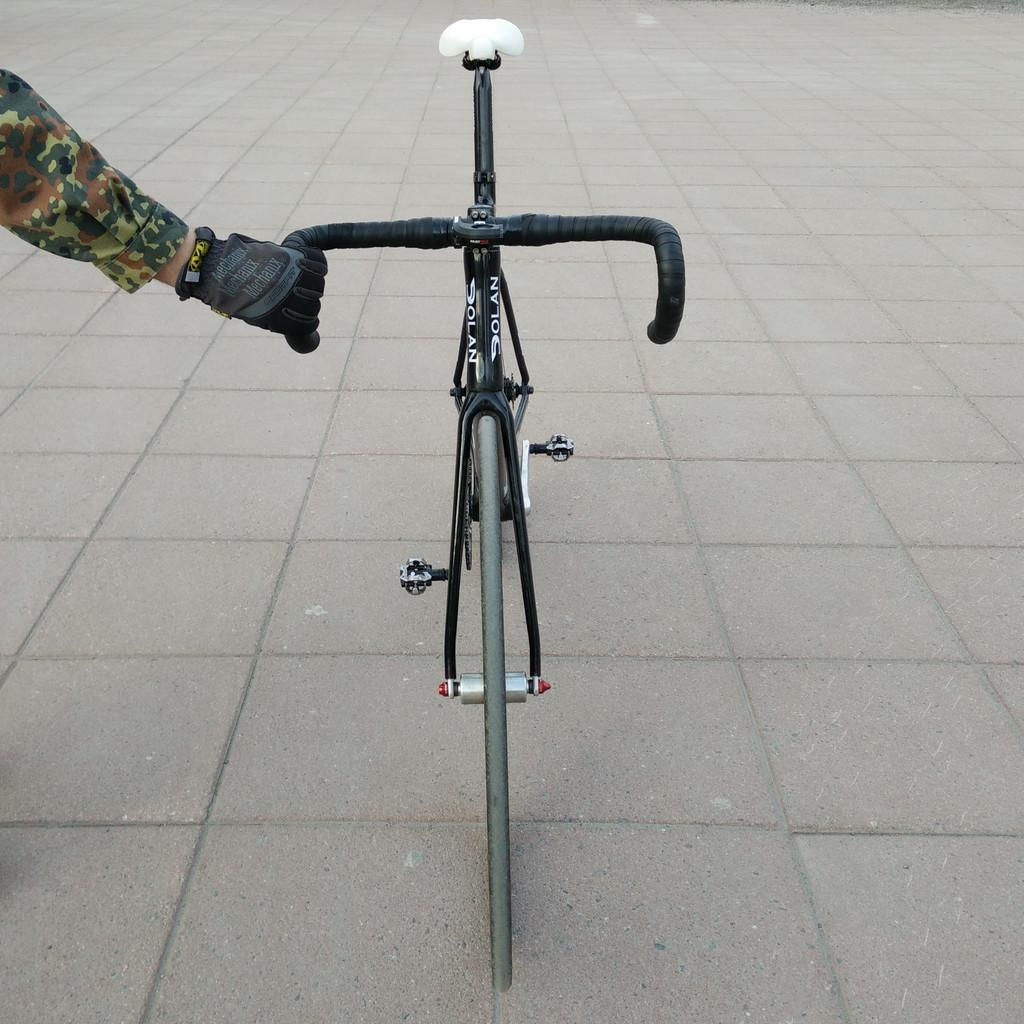What is the person's hand holding in the image? The person's hand is holding the handle of a cycle. How is the cycle positioned in the image? The cycle is parked on the ground. What part of the cycle can be seen in the image? The wheel and pedals of the cycle are visible. What is the color of the seat on the cycle? The seat on the cycle is white. What type of building is visible in the background of the image? There is no building visible in the background of the image; it only shows a person's hand holding the handle of a cycle. 